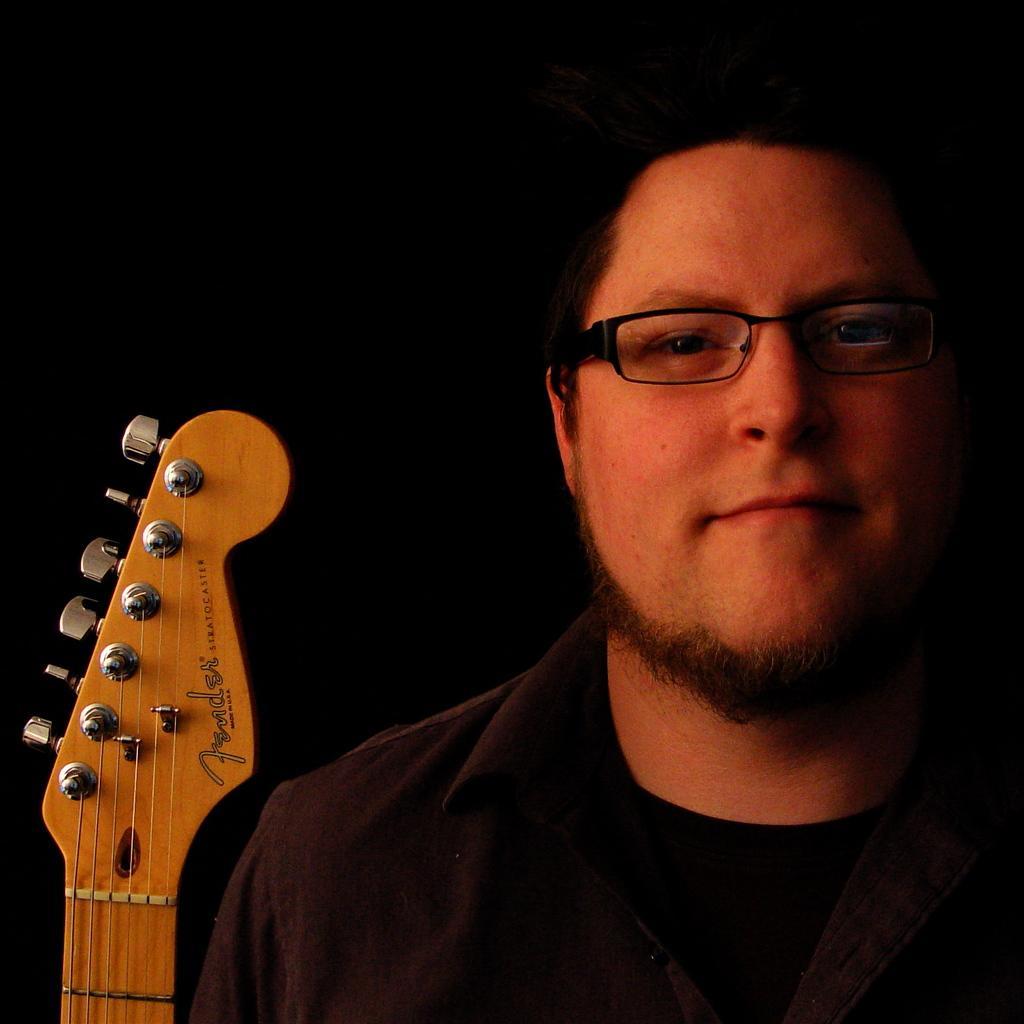Can you describe this image briefly? In this picture a black shirt guy who is wearing spectacles and has a light beard is standing,beside him a guitar is placed and the background is black colored. 